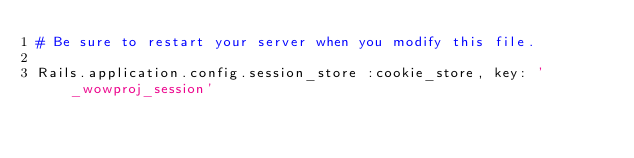<code> <loc_0><loc_0><loc_500><loc_500><_Ruby_># Be sure to restart your server when you modify this file.

Rails.application.config.session_store :cookie_store, key: '_wowproj_session'
</code> 